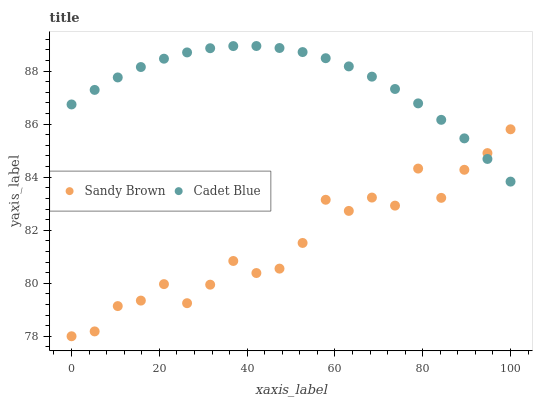Does Sandy Brown have the minimum area under the curve?
Answer yes or no. Yes. Does Cadet Blue have the maximum area under the curve?
Answer yes or no. Yes. Does Sandy Brown have the maximum area under the curve?
Answer yes or no. No. Is Cadet Blue the smoothest?
Answer yes or no. Yes. Is Sandy Brown the roughest?
Answer yes or no. Yes. Is Sandy Brown the smoothest?
Answer yes or no. No. Does Sandy Brown have the lowest value?
Answer yes or no. Yes. Does Cadet Blue have the highest value?
Answer yes or no. Yes. Does Sandy Brown have the highest value?
Answer yes or no. No. Does Cadet Blue intersect Sandy Brown?
Answer yes or no. Yes. Is Cadet Blue less than Sandy Brown?
Answer yes or no. No. Is Cadet Blue greater than Sandy Brown?
Answer yes or no. No. 